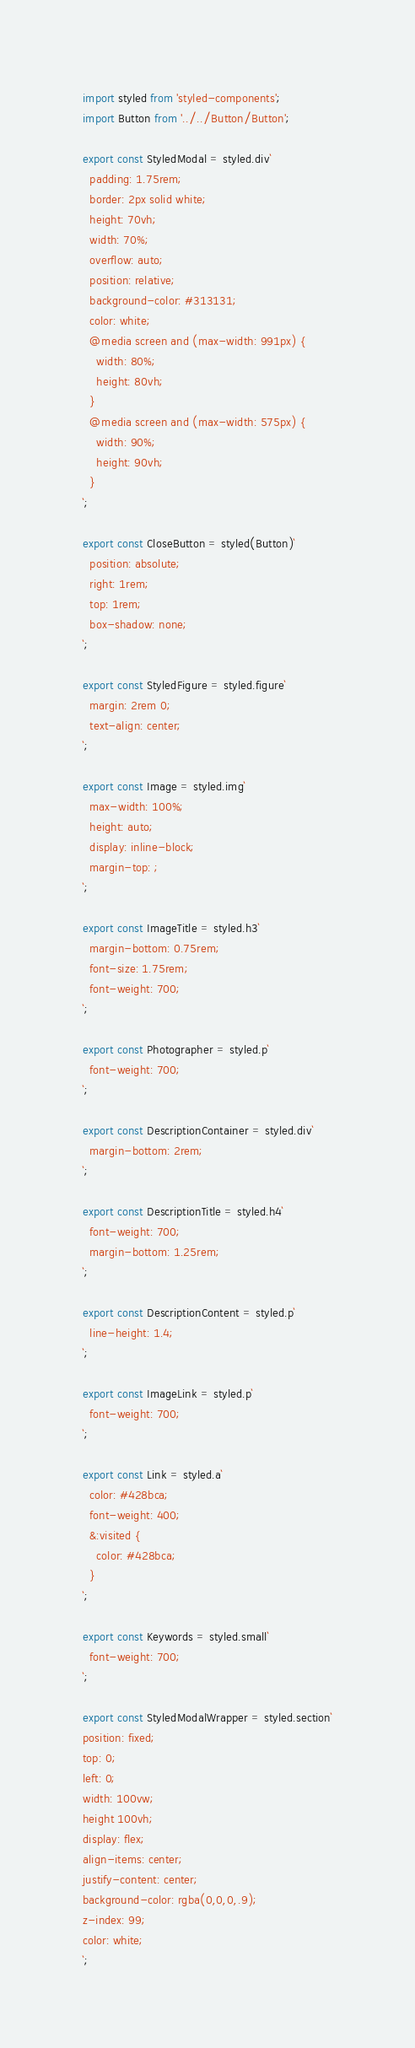Convert code to text. <code><loc_0><loc_0><loc_500><loc_500><_JavaScript_>import styled from 'styled-components';
import Button from '../../Button/Button';

export const StyledModal = styled.div`
  padding: 1.75rem;
  border: 2px solid white;
  height: 70vh;
  width: 70%;
  overflow: auto;
  position: relative;
  background-color: #313131;
  color: white;
  @media screen and (max-width: 991px) {
    width: 80%;
    height: 80vh;
  }
  @media screen and (max-width: 575px) {
    width: 90%;
    height: 90vh;
  }
`;

export const CloseButton = styled(Button)`
  position: absolute;
  right: 1rem;
  top: 1rem;
  box-shadow: none;
`;

export const StyledFigure = styled.figure`
  margin: 2rem 0;
  text-align: center;
`;

export const Image = styled.img`
  max-width: 100%;
  height: auto;
  display: inline-block;
  margin-top: ;
`;

export const ImageTitle = styled.h3`
  margin-bottom: 0.75rem;
  font-size: 1.75rem;
  font-weight: 700;
`;

export const Photographer = styled.p`
  font-weight: 700;
`;

export const DescriptionContainer = styled.div`
  margin-bottom: 2rem;
`;

export const DescriptionTitle = styled.h4`
  font-weight: 700;
  margin-bottom: 1.25rem;
`;

export const DescriptionContent = styled.p`
  line-height: 1.4;
`;

export const ImageLink = styled.p`
  font-weight: 700;
`;

export const Link = styled.a`
  color: #428bca;
  font-weight: 400;
  &:visited {
    color: #428bca;
  }
`;

export const Keywords = styled.small`
  font-weight: 700;
`;

export const StyledModalWrapper = styled.section`
position: fixed;
top: 0;
left: 0;
width: 100vw;
height 100vh;
display: flex;
align-items: center;
justify-content: center; 
background-color: rgba(0,0,0,.9); 
z-index: 99;
color: white;
`;
</code> 